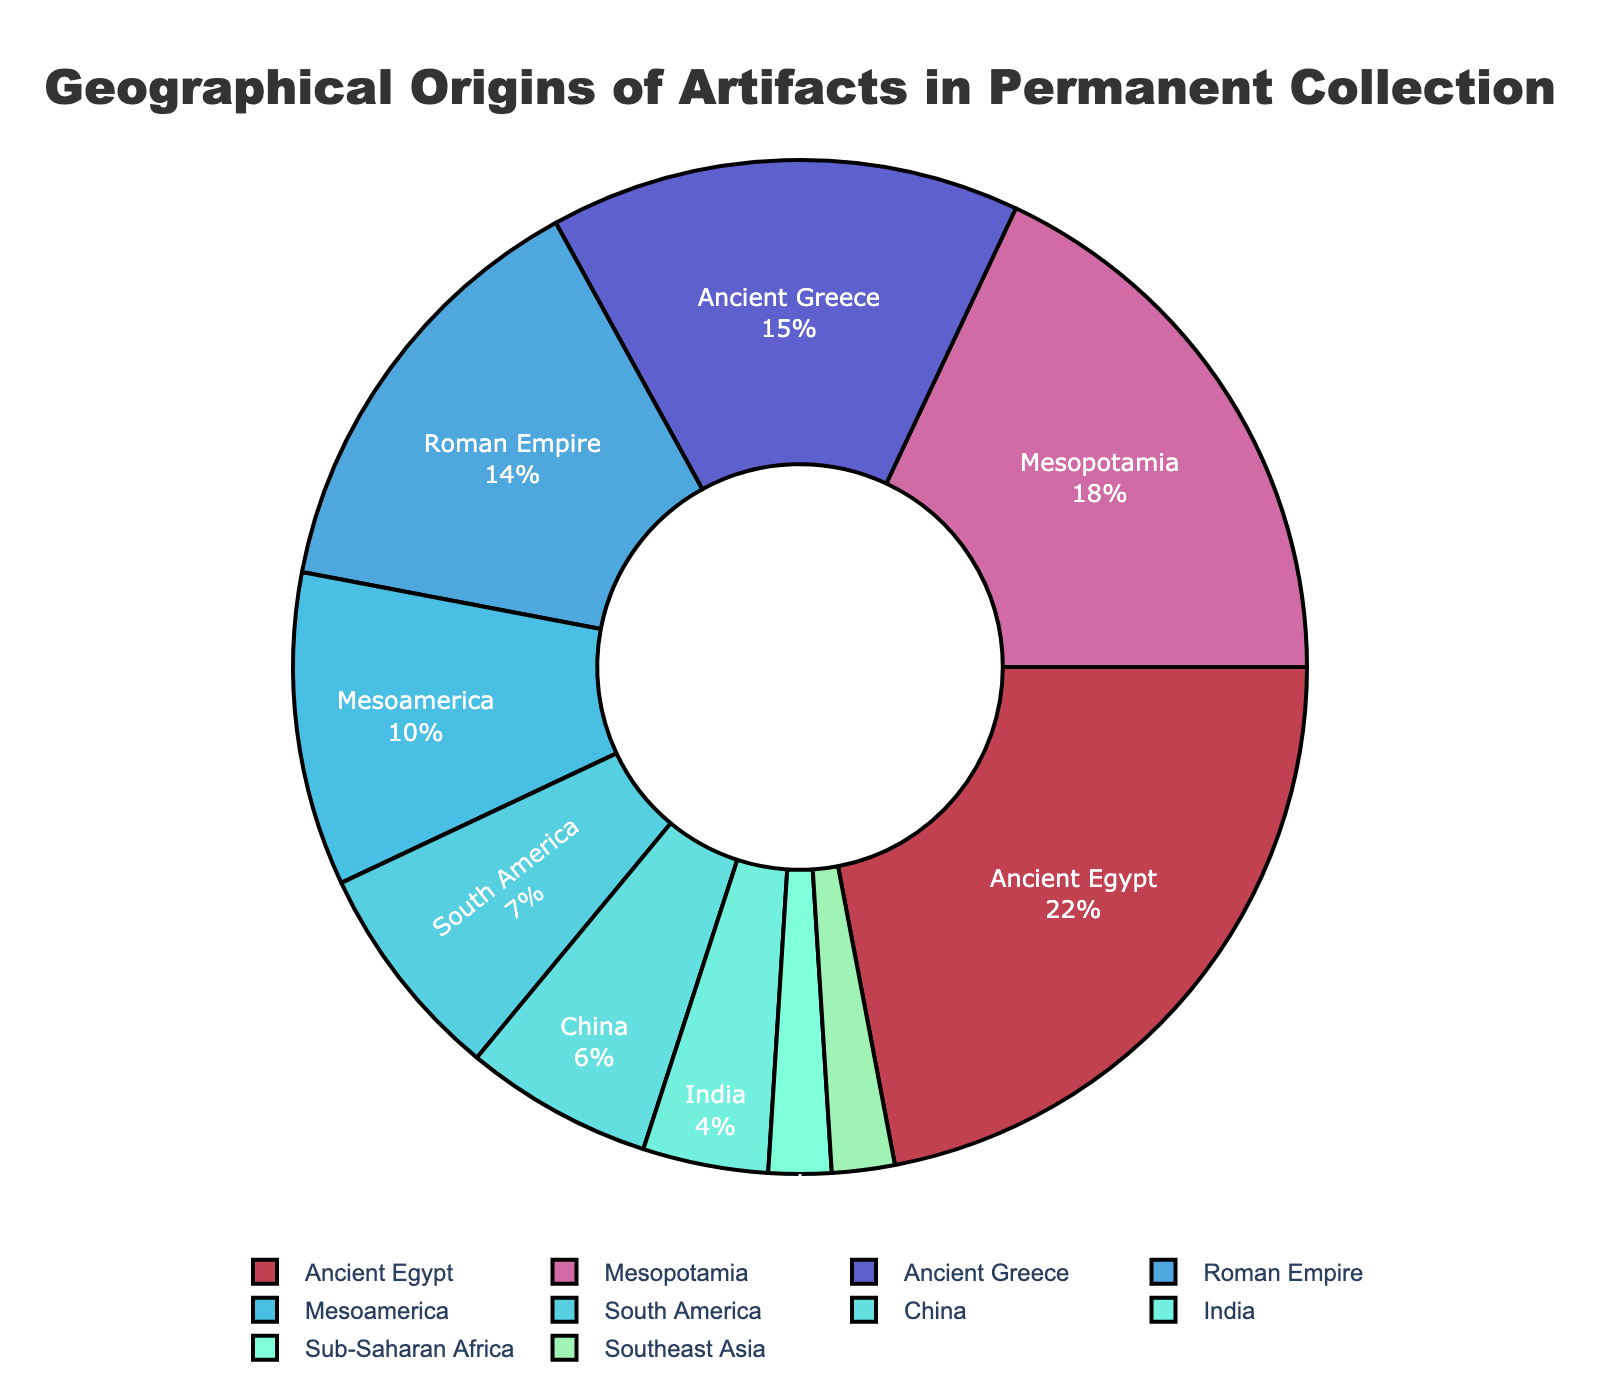What region has the largest percentage of artifacts in the permanent collection? The region with the largest percentage of artifacts in the permanent collection is the one with the largest slice in the pie chart. The largest slice is labeled “Ancient Egypt” with 22%.
Answer: Ancient Egypt Which region contributes the least to the museum's permanent collection? The smallest slice in the pie chart represents the region contributing the least. Both "Sub-Saharan Africa" and "Southeast Asia" have the smallest slices at 2% each.
Answer: Sub-Saharan Africa and Southeast Asia What is the combined percentage of artifacts from Ancient Greece and the Roman Empire? The percentages for Ancient Greece and the Roman Empire are 15% and 14%, respectively. Adding these together gives: 15% + 14% = 29%.
Answer: 29% How does the percentage of artifacts from Mesopotamia compare to China? Mesopotamia has 18% of the artifacts, while China has 6%. Thus, Mesopotamia has a higher percentage.
Answer: Mesopotamia What fraction of the collection is made up by artifacts from the Roman Empire compared to South America? The Roman Empire contributes 14%, and South America contributes 7%. The fraction of Roman Empire artifacts to South American artifacts is 14/7 = 2.
Answer: 2 Which region falls between and closest to Ancient Greece and Mesopotamia in the percentage of artifacts? To find a region whose percentage lies between Ancient Greece (15%) and Mesopotamia (18%), looking at the chart, there are no regions whose percentage is exactly between these values. The closest one is the Roman Empire at 14%, just below Greece.
Answer: Roman Empire What is the average percentage of artifacts from Ancient Greece, Mesoamerica, and India? To find the average: (15% + 10% + 4%) / 3 = 29% / 3 ≈ 9.67%.
Answer: 9.67% If India and Sub-Saharan Africa's percentages are combined, can they surpass the percentage of Mesoamerica alone? India has 4% and Sub-Saharan Africa has 2%. Combined, they make 4% + 2% = 6%, which is still less than Mesoamerica's 10%.
Answer: No Which region has a percentage closest to the average percentage share of all regions presented? First, find the average of all percentages: (22% + 18% + 15% + 14% + 10% + 7% + 6% + 4% + 2% + 2%) / 10 = 100% / 10 = 10%. Mesoamerica, at 10%, is exactly the average.
Answer: Mesoamerica What is the total percentage of artifacts from regions outside the top three contributors? The top three regions are Ancient Egypt (22%), Mesopotamia (18%), and Ancient Greece (15%). Their combined percentage is 22% + 18% + 15% = 55%. The total percentage is 100%, so the percentage from other regions is 100% - 55% = 45%.
Answer: 45% 